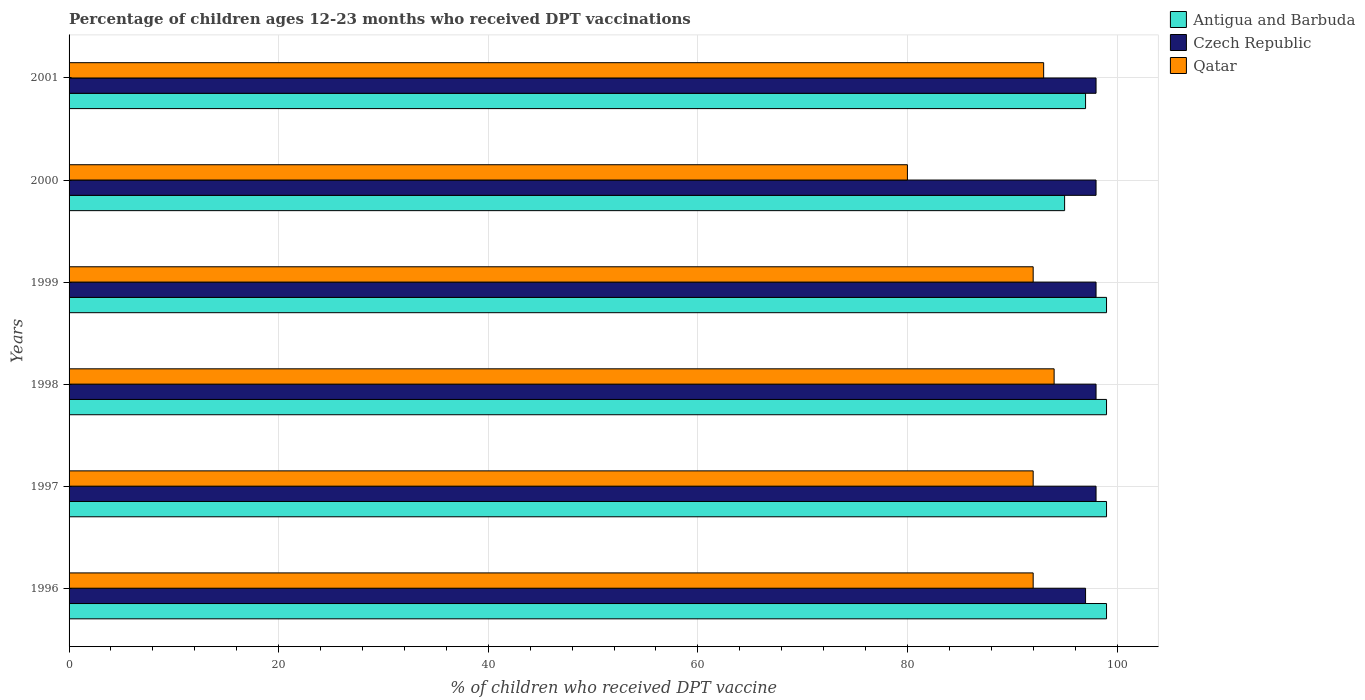How many different coloured bars are there?
Give a very brief answer. 3. How many groups of bars are there?
Your response must be concise. 6. Are the number of bars on each tick of the Y-axis equal?
Provide a succinct answer. Yes. How many bars are there on the 4th tick from the bottom?
Offer a terse response. 3. What is the label of the 2nd group of bars from the top?
Provide a short and direct response. 2000. In how many cases, is the number of bars for a given year not equal to the number of legend labels?
Offer a terse response. 0. What is the percentage of children who received DPT vaccination in Czech Republic in 1998?
Give a very brief answer. 98. Across all years, what is the maximum percentage of children who received DPT vaccination in Qatar?
Your answer should be compact. 94. Across all years, what is the minimum percentage of children who received DPT vaccination in Antigua and Barbuda?
Keep it short and to the point. 95. In which year was the percentage of children who received DPT vaccination in Czech Republic maximum?
Make the answer very short. 1997. In which year was the percentage of children who received DPT vaccination in Qatar minimum?
Offer a terse response. 2000. What is the total percentage of children who received DPT vaccination in Qatar in the graph?
Provide a short and direct response. 543. What is the difference between the percentage of children who received DPT vaccination in Czech Republic in 1999 and that in 2000?
Keep it short and to the point. 0. What is the difference between the percentage of children who received DPT vaccination in Antigua and Barbuda in 2000 and the percentage of children who received DPT vaccination in Czech Republic in 1998?
Your answer should be very brief. -3. What is the average percentage of children who received DPT vaccination in Qatar per year?
Give a very brief answer. 90.5. In how many years, is the percentage of children who received DPT vaccination in Czech Republic greater than 20 %?
Give a very brief answer. 6. Is the difference between the percentage of children who received DPT vaccination in Qatar in 1996 and 1999 greater than the difference between the percentage of children who received DPT vaccination in Czech Republic in 1996 and 1999?
Your answer should be compact. Yes. What is the difference between the highest and the lowest percentage of children who received DPT vaccination in Antigua and Barbuda?
Make the answer very short. 4. In how many years, is the percentage of children who received DPT vaccination in Antigua and Barbuda greater than the average percentage of children who received DPT vaccination in Antigua and Barbuda taken over all years?
Offer a terse response. 4. What does the 2nd bar from the top in 1999 represents?
Your response must be concise. Czech Republic. What does the 1st bar from the bottom in 1996 represents?
Provide a succinct answer. Antigua and Barbuda. What is the difference between two consecutive major ticks on the X-axis?
Your answer should be very brief. 20. Are the values on the major ticks of X-axis written in scientific E-notation?
Ensure brevity in your answer.  No. Does the graph contain any zero values?
Your answer should be very brief. No. Does the graph contain grids?
Your answer should be very brief. Yes. Where does the legend appear in the graph?
Keep it short and to the point. Top right. How many legend labels are there?
Ensure brevity in your answer.  3. What is the title of the graph?
Offer a terse response. Percentage of children ages 12-23 months who received DPT vaccinations. What is the label or title of the X-axis?
Your answer should be very brief. % of children who received DPT vaccine. What is the % of children who received DPT vaccine of Czech Republic in 1996?
Offer a terse response. 97. What is the % of children who received DPT vaccine in Qatar in 1996?
Ensure brevity in your answer.  92. What is the % of children who received DPT vaccine of Qatar in 1997?
Provide a short and direct response. 92. What is the % of children who received DPT vaccine of Czech Republic in 1998?
Offer a terse response. 98. What is the % of children who received DPT vaccine in Qatar in 1998?
Your response must be concise. 94. What is the % of children who received DPT vaccine in Czech Republic in 1999?
Provide a short and direct response. 98. What is the % of children who received DPT vaccine in Qatar in 1999?
Keep it short and to the point. 92. What is the % of children who received DPT vaccine of Antigua and Barbuda in 2000?
Your response must be concise. 95. What is the % of children who received DPT vaccine in Czech Republic in 2000?
Make the answer very short. 98. What is the % of children who received DPT vaccine of Antigua and Barbuda in 2001?
Make the answer very short. 97. What is the % of children who received DPT vaccine of Czech Republic in 2001?
Your response must be concise. 98. What is the % of children who received DPT vaccine in Qatar in 2001?
Keep it short and to the point. 93. Across all years, what is the maximum % of children who received DPT vaccine in Czech Republic?
Offer a very short reply. 98. Across all years, what is the maximum % of children who received DPT vaccine of Qatar?
Give a very brief answer. 94. Across all years, what is the minimum % of children who received DPT vaccine in Antigua and Barbuda?
Give a very brief answer. 95. Across all years, what is the minimum % of children who received DPT vaccine of Czech Republic?
Provide a short and direct response. 97. What is the total % of children who received DPT vaccine in Antigua and Barbuda in the graph?
Give a very brief answer. 588. What is the total % of children who received DPT vaccine of Czech Republic in the graph?
Ensure brevity in your answer.  587. What is the total % of children who received DPT vaccine in Qatar in the graph?
Your answer should be compact. 543. What is the difference between the % of children who received DPT vaccine in Antigua and Barbuda in 1996 and that in 1997?
Make the answer very short. 0. What is the difference between the % of children who received DPT vaccine of Antigua and Barbuda in 1996 and that in 1998?
Make the answer very short. 0. What is the difference between the % of children who received DPT vaccine in Qatar in 1996 and that in 1998?
Your answer should be very brief. -2. What is the difference between the % of children who received DPT vaccine in Antigua and Barbuda in 1996 and that in 1999?
Offer a terse response. 0. What is the difference between the % of children who received DPT vaccine of Czech Republic in 1996 and that in 1999?
Offer a terse response. -1. What is the difference between the % of children who received DPT vaccine of Qatar in 1996 and that in 1999?
Ensure brevity in your answer.  0. What is the difference between the % of children who received DPT vaccine of Antigua and Barbuda in 1996 and that in 2000?
Your response must be concise. 4. What is the difference between the % of children who received DPT vaccine in Czech Republic in 1996 and that in 2000?
Make the answer very short. -1. What is the difference between the % of children who received DPT vaccine of Qatar in 1996 and that in 2000?
Give a very brief answer. 12. What is the difference between the % of children who received DPT vaccine in Antigua and Barbuda in 1996 and that in 2001?
Your answer should be compact. 2. What is the difference between the % of children who received DPT vaccine in Qatar in 1996 and that in 2001?
Offer a very short reply. -1. What is the difference between the % of children who received DPT vaccine of Qatar in 1997 and that in 1998?
Ensure brevity in your answer.  -2. What is the difference between the % of children who received DPT vaccine in Czech Republic in 1997 and that in 1999?
Your answer should be very brief. 0. What is the difference between the % of children who received DPT vaccine of Czech Republic in 1997 and that in 2000?
Provide a succinct answer. 0. What is the difference between the % of children who received DPT vaccine of Qatar in 1997 and that in 2000?
Your answer should be compact. 12. What is the difference between the % of children who received DPT vaccine in Antigua and Barbuda in 1997 and that in 2001?
Provide a short and direct response. 2. What is the difference between the % of children who received DPT vaccine in Antigua and Barbuda in 1998 and that in 1999?
Make the answer very short. 0. What is the difference between the % of children who received DPT vaccine of Czech Republic in 1998 and that in 1999?
Keep it short and to the point. 0. What is the difference between the % of children who received DPT vaccine of Antigua and Barbuda in 1998 and that in 2000?
Make the answer very short. 4. What is the difference between the % of children who received DPT vaccine of Czech Republic in 1998 and that in 2000?
Your answer should be very brief. 0. What is the difference between the % of children who received DPT vaccine in Czech Republic in 1998 and that in 2001?
Keep it short and to the point. 0. What is the difference between the % of children who received DPT vaccine in Czech Republic in 1999 and that in 2000?
Your answer should be very brief. 0. What is the difference between the % of children who received DPT vaccine in Qatar in 1999 and that in 2000?
Offer a terse response. 12. What is the difference between the % of children who received DPT vaccine in Antigua and Barbuda in 1999 and that in 2001?
Your answer should be very brief. 2. What is the difference between the % of children who received DPT vaccine in Czech Republic in 1999 and that in 2001?
Your answer should be very brief. 0. What is the difference between the % of children who received DPT vaccine in Qatar in 1999 and that in 2001?
Ensure brevity in your answer.  -1. What is the difference between the % of children who received DPT vaccine of Qatar in 2000 and that in 2001?
Give a very brief answer. -13. What is the difference between the % of children who received DPT vaccine of Antigua and Barbuda in 1996 and the % of children who received DPT vaccine of Czech Republic in 1997?
Ensure brevity in your answer.  1. What is the difference between the % of children who received DPT vaccine in Antigua and Barbuda in 1996 and the % of children who received DPT vaccine in Qatar in 1997?
Keep it short and to the point. 7. What is the difference between the % of children who received DPT vaccine in Antigua and Barbuda in 1996 and the % of children who received DPT vaccine in Czech Republic in 1999?
Your answer should be compact. 1. What is the difference between the % of children who received DPT vaccine in Antigua and Barbuda in 1996 and the % of children who received DPT vaccine in Qatar in 1999?
Provide a succinct answer. 7. What is the difference between the % of children who received DPT vaccine of Czech Republic in 1996 and the % of children who received DPT vaccine of Qatar in 1999?
Make the answer very short. 5. What is the difference between the % of children who received DPT vaccine in Antigua and Barbuda in 1996 and the % of children who received DPT vaccine in Czech Republic in 2000?
Offer a very short reply. 1. What is the difference between the % of children who received DPT vaccine in Czech Republic in 1996 and the % of children who received DPT vaccine in Qatar in 2000?
Offer a terse response. 17. What is the difference between the % of children who received DPT vaccine of Antigua and Barbuda in 1996 and the % of children who received DPT vaccine of Qatar in 2001?
Give a very brief answer. 6. What is the difference between the % of children who received DPT vaccine of Antigua and Barbuda in 1997 and the % of children who received DPT vaccine of Czech Republic in 1998?
Ensure brevity in your answer.  1. What is the difference between the % of children who received DPT vaccine in Antigua and Barbuda in 1997 and the % of children who received DPT vaccine in Qatar in 1998?
Your response must be concise. 5. What is the difference between the % of children who received DPT vaccine in Czech Republic in 1997 and the % of children who received DPT vaccine in Qatar in 1999?
Ensure brevity in your answer.  6. What is the difference between the % of children who received DPT vaccine in Antigua and Barbuda in 1997 and the % of children who received DPT vaccine in Czech Republic in 2000?
Offer a terse response. 1. What is the difference between the % of children who received DPT vaccine in Antigua and Barbuda in 1997 and the % of children who received DPT vaccine in Qatar in 2000?
Provide a short and direct response. 19. What is the difference between the % of children who received DPT vaccine in Czech Republic in 1997 and the % of children who received DPT vaccine in Qatar in 2000?
Give a very brief answer. 18. What is the difference between the % of children who received DPT vaccine of Czech Republic in 1997 and the % of children who received DPT vaccine of Qatar in 2001?
Offer a very short reply. 5. What is the difference between the % of children who received DPT vaccine of Antigua and Barbuda in 1998 and the % of children who received DPT vaccine of Czech Republic in 1999?
Offer a very short reply. 1. What is the difference between the % of children who received DPT vaccine in Czech Republic in 1998 and the % of children who received DPT vaccine in Qatar in 1999?
Make the answer very short. 6. What is the difference between the % of children who received DPT vaccine of Antigua and Barbuda in 1998 and the % of children who received DPT vaccine of Czech Republic in 2000?
Your response must be concise. 1. What is the difference between the % of children who received DPT vaccine of Antigua and Barbuda in 1998 and the % of children who received DPT vaccine of Qatar in 2000?
Keep it short and to the point. 19. What is the difference between the % of children who received DPT vaccine in Antigua and Barbuda in 1998 and the % of children who received DPT vaccine in Czech Republic in 2001?
Keep it short and to the point. 1. What is the difference between the % of children who received DPT vaccine of Antigua and Barbuda in 1998 and the % of children who received DPT vaccine of Qatar in 2001?
Provide a succinct answer. 6. What is the difference between the % of children who received DPT vaccine of Czech Republic in 1998 and the % of children who received DPT vaccine of Qatar in 2001?
Keep it short and to the point. 5. What is the difference between the % of children who received DPT vaccine in Czech Republic in 1999 and the % of children who received DPT vaccine in Qatar in 2000?
Offer a very short reply. 18. What is the difference between the % of children who received DPT vaccine in Czech Republic in 2000 and the % of children who received DPT vaccine in Qatar in 2001?
Offer a terse response. 5. What is the average % of children who received DPT vaccine in Antigua and Barbuda per year?
Provide a succinct answer. 98. What is the average % of children who received DPT vaccine of Czech Republic per year?
Offer a very short reply. 97.83. What is the average % of children who received DPT vaccine in Qatar per year?
Ensure brevity in your answer.  90.5. In the year 1996, what is the difference between the % of children who received DPT vaccine of Antigua and Barbuda and % of children who received DPT vaccine of Czech Republic?
Your answer should be compact. 2. In the year 1997, what is the difference between the % of children who received DPT vaccine in Antigua and Barbuda and % of children who received DPT vaccine in Czech Republic?
Offer a very short reply. 1. In the year 1998, what is the difference between the % of children who received DPT vaccine in Czech Republic and % of children who received DPT vaccine in Qatar?
Keep it short and to the point. 4. In the year 1999, what is the difference between the % of children who received DPT vaccine in Antigua and Barbuda and % of children who received DPT vaccine in Czech Republic?
Your response must be concise. 1. In the year 2000, what is the difference between the % of children who received DPT vaccine of Antigua and Barbuda and % of children who received DPT vaccine of Qatar?
Make the answer very short. 15. In the year 2001, what is the difference between the % of children who received DPT vaccine of Antigua and Barbuda and % of children who received DPT vaccine of Czech Republic?
Your response must be concise. -1. In the year 2001, what is the difference between the % of children who received DPT vaccine of Czech Republic and % of children who received DPT vaccine of Qatar?
Provide a short and direct response. 5. What is the ratio of the % of children who received DPT vaccine of Antigua and Barbuda in 1996 to that in 1997?
Make the answer very short. 1. What is the ratio of the % of children who received DPT vaccine of Qatar in 1996 to that in 1997?
Your answer should be compact. 1. What is the ratio of the % of children who received DPT vaccine in Czech Republic in 1996 to that in 1998?
Give a very brief answer. 0.99. What is the ratio of the % of children who received DPT vaccine in Qatar in 1996 to that in 1998?
Your answer should be compact. 0.98. What is the ratio of the % of children who received DPT vaccine of Antigua and Barbuda in 1996 to that in 1999?
Keep it short and to the point. 1. What is the ratio of the % of children who received DPT vaccine in Czech Republic in 1996 to that in 1999?
Provide a short and direct response. 0.99. What is the ratio of the % of children who received DPT vaccine of Qatar in 1996 to that in 1999?
Ensure brevity in your answer.  1. What is the ratio of the % of children who received DPT vaccine of Antigua and Barbuda in 1996 to that in 2000?
Provide a succinct answer. 1.04. What is the ratio of the % of children who received DPT vaccine of Czech Republic in 1996 to that in 2000?
Ensure brevity in your answer.  0.99. What is the ratio of the % of children who received DPT vaccine in Qatar in 1996 to that in 2000?
Provide a succinct answer. 1.15. What is the ratio of the % of children who received DPT vaccine in Antigua and Barbuda in 1996 to that in 2001?
Provide a succinct answer. 1.02. What is the ratio of the % of children who received DPT vaccine of Antigua and Barbuda in 1997 to that in 1998?
Offer a very short reply. 1. What is the ratio of the % of children who received DPT vaccine of Qatar in 1997 to that in 1998?
Provide a short and direct response. 0.98. What is the ratio of the % of children who received DPT vaccine of Antigua and Barbuda in 1997 to that in 1999?
Give a very brief answer. 1. What is the ratio of the % of children who received DPT vaccine in Qatar in 1997 to that in 1999?
Offer a terse response. 1. What is the ratio of the % of children who received DPT vaccine in Antigua and Barbuda in 1997 to that in 2000?
Your answer should be very brief. 1.04. What is the ratio of the % of children who received DPT vaccine of Qatar in 1997 to that in 2000?
Offer a very short reply. 1.15. What is the ratio of the % of children who received DPT vaccine of Antigua and Barbuda in 1997 to that in 2001?
Ensure brevity in your answer.  1.02. What is the ratio of the % of children who received DPT vaccine in Qatar in 1998 to that in 1999?
Offer a very short reply. 1.02. What is the ratio of the % of children who received DPT vaccine in Antigua and Barbuda in 1998 to that in 2000?
Provide a short and direct response. 1.04. What is the ratio of the % of children who received DPT vaccine of Qatar in 1998 to that in 2000?
Your answer should be very brief. 1.18. What is the ratio of the % of children who received DPT vaccine in Antigua and Barbuda in 1998 to that in 2001?
Give a very brief answer. 1.02. What is the ratio of the % of children who received DPT vaccine of Qatar in 1998 to that in 2001?
Offer a very short reply. 1.01. What is the ratio of the % of children who received DPT vaccine of Antigua and Barbuda in 1999 to that in 2000?
Offer a very short reply. 1.04. What is the ratio of the % of children who received DPT vaccine of Czech Republic in 1999 to that in 2000?
Ensure brevity in your answer.  1. What is the ratio of the % of children who received DPT vaccine of Qatar in 1999 to that in 2000?
Give a very brief answer. 1.15. What is the ratio of the % of children who received DPT vaccine of Antigua and Barbuda in 1999 to that in 2001?
Provide a short and direct response. 1.02. What is the ratio of the % of children who received DPT vaccine in Qatar in 1999 to that in 2001?
Provide a succinct answer. 0.99. What is the ratio of the % of children who received DPT vaccine in Antigua and Barbuda in 2000 to that in 2001?
Your response must be concise. 0.98. What is the ratio of the % of children who received DPT vaccine in Qatar in 2000 to that in 2001?
Offer a very short reply. 0.86. What is the difference between the highest and the second highest % of children who received DPT vaccine of Qatar?
Your answer should be compact. 1. What is the difference between the highest and the lowest % of children who received DPT vaccine in Antigua and Barbuda?
Your answer should be very brief. 4. What is the difference between the highest and the lowest % of children who received DPT vaccine in Czech Republic?
Keep it short and to the point. 1. 